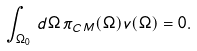Convert formula to latex. <formula><loc_0><loc_0><loc_500><loc_500>\int _ { \Omega _ { 0 } } \, d \Omega \, \pi _ { C M } ( \Omega ) v ( \Omega ) = 0 .</formula> 